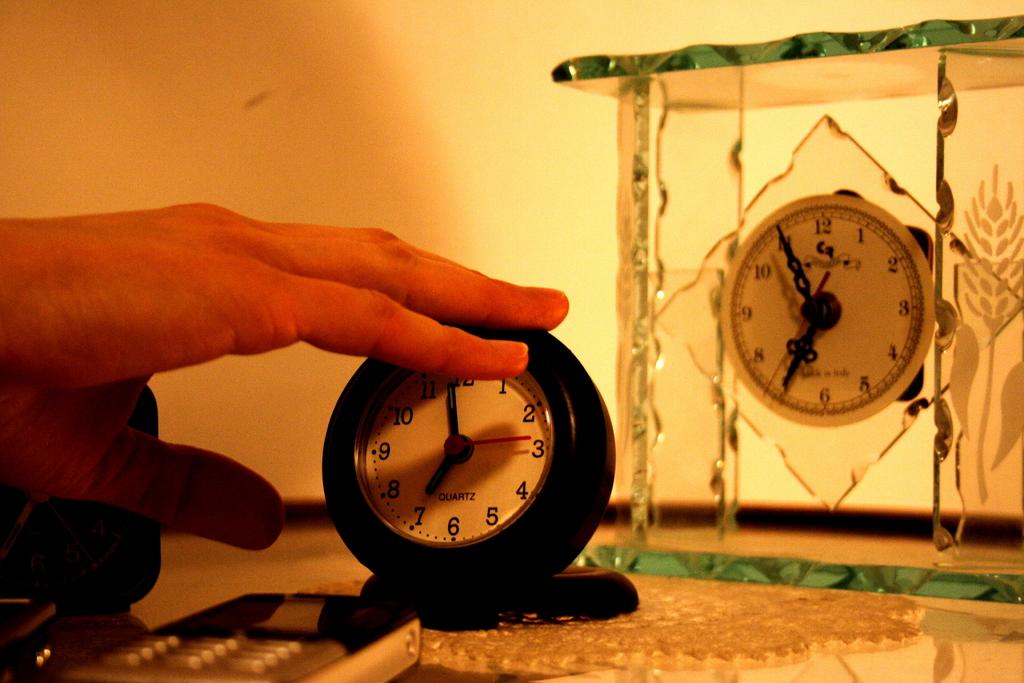<image>
Offer a succinct explanation of the picture presented. a clock with 1 thru 12 on the front of it 